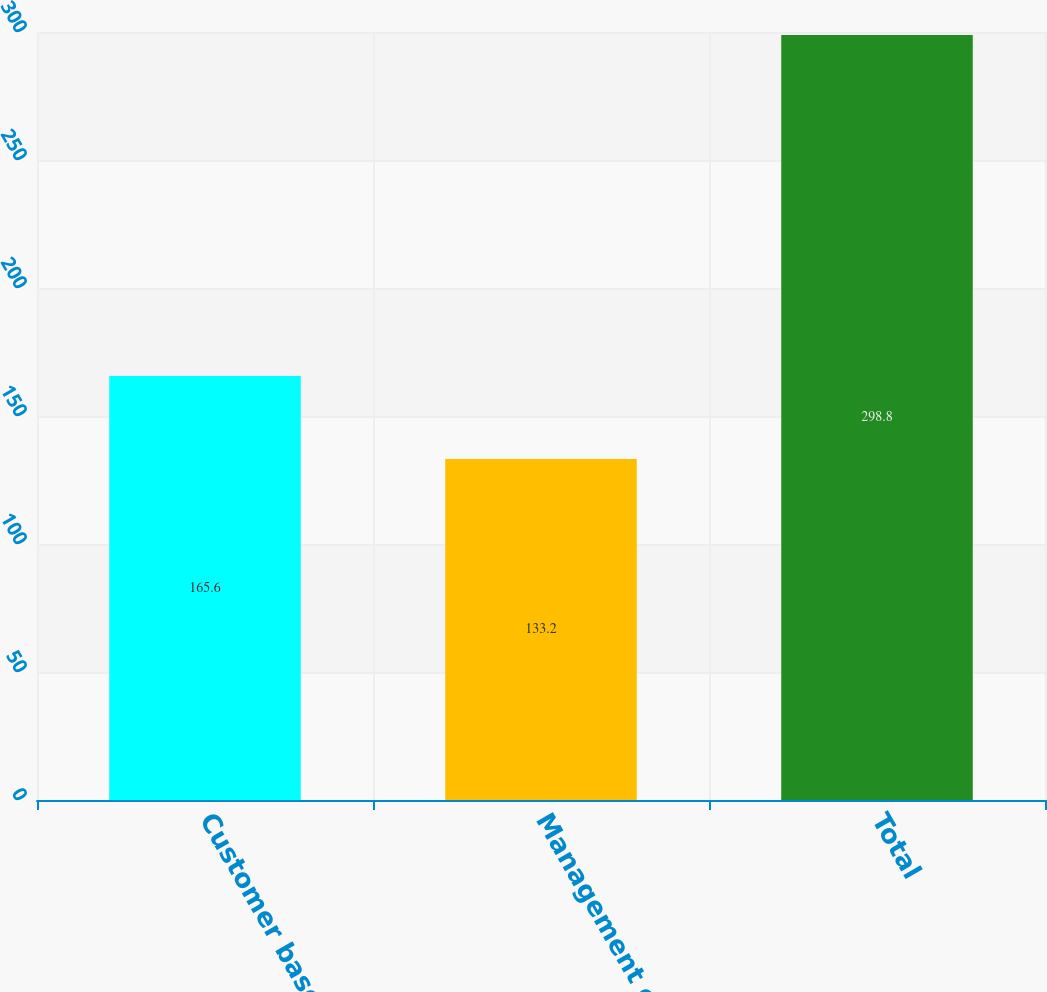Convert chart. <chart><loc_0><loc_0><loc_500><loc_500><bar_chart><fcel>Customer base<fcel>Management contracts<fcel>Total<nl><fcel>165.6<fcel>133.2<fcel>298.8<nl></chart> 